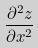<formula> <loc_0><loc_0><loc_500><loc_500>\frac { \partial ^ { 2 } z } { \partial x ^ { 2 } }</formula> 